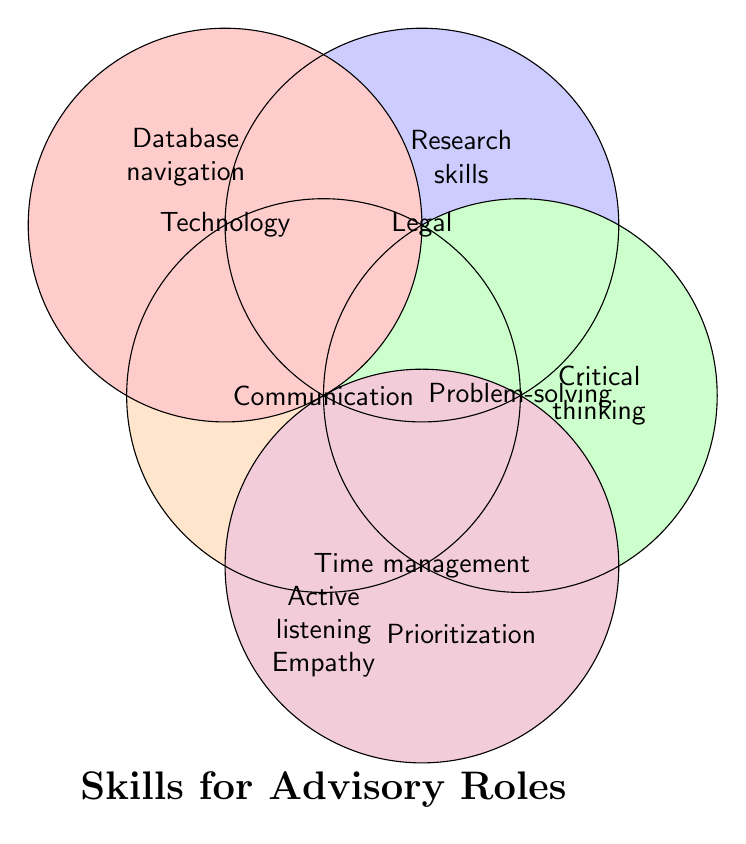What are the categories represented in the diagram? The diagram represents five main categories: Communication, Legal, Problem-solving, Technology, and Time management. These are clearly labeled within the colored circles.
Answer: Communication, Legal, Problem-solving, Technology, Time management What are the skills listed under the Communication category? The Communication category, represented by the orange circle, lists the following skills: Active listening and Empathy. This information is displayed within the circle labeled "Communication."
Answer: Active listening, Empathy Which category includes Research skills? The skill "Research skills" is positioned adjacent to the circle labeled "Legal." It is thus categorized under the Legal category.
Answer: Legal Name a skill that falls under both Problem-solving and Time management. Upon examination, no skills overlap between the Problem-solving and Time management categories in the Venn diagram. Skills are unique to each circle.
Answer: None Which category has the skill Basic legal knowledge? The skill "Basic legal knowledge" is associated with the Legal category, which is part of the blue circle.
Answer: Legal How many skills are listed under the Technology category? By counting the skills displayed near the Technology circle, we see that there are two skills: Database navigation and Case management software.
Answer: Two What is the number of skills combined across all categories? Adding the skills listed under each category: Communication (2), Legal (2), Problem-solving (3), Technology (2), and Time management (2). The total count is 2 + 2 + 3 + 2 + 2 = 11 skills.
Answer: 11 Which categories do not overlap with any other categories? Observing the Venn diagram, we see that all categories are placed distinctly without overlapping regions. Therefore, none of the categories overlap.
Answer: None Identify a unique skill tied to the Interpersonal category that is not visible in the provided information. The Interpersonal category includes Patience and Cultural sensitivity, but the diagram doesn't show any skills named "Interpersonal." Therefore, to identify a skill tied to Interpersonal, use one mentioned in the input data.
Answer: Patience Which category includes the skill Decision-making? The skill "Decision-making" is categorized under Problem-solving, as indicated by the location near the Problem-solving circle.
Answer: Problem-solving 